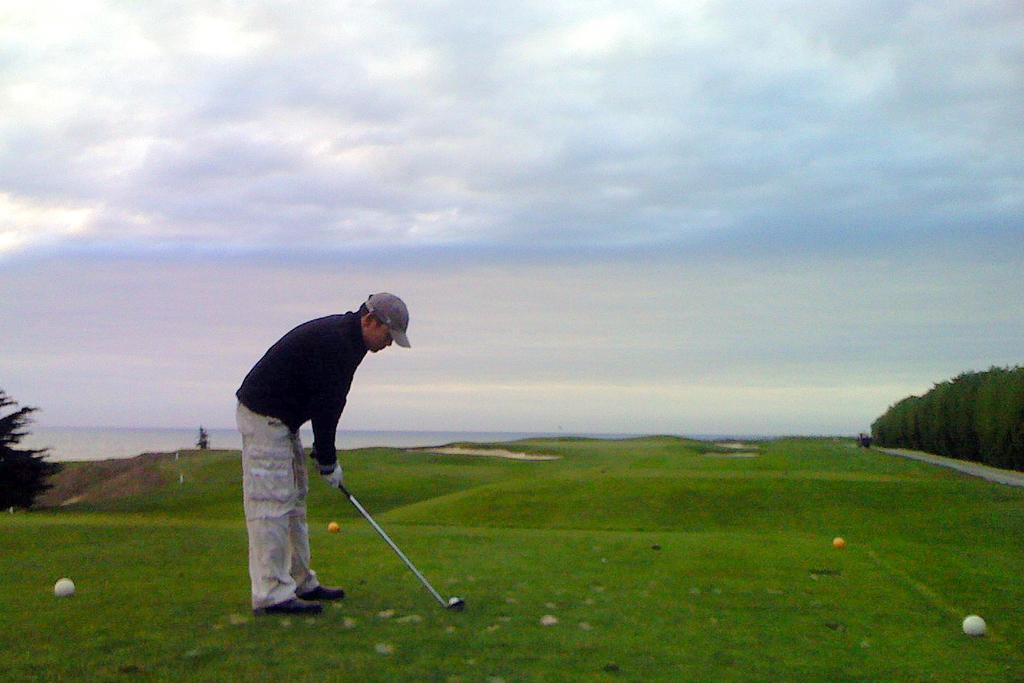Can you describe this image briefly? The man in black T-shirt is holding hockey stick in his hand and he is playing hockey. At the bottom of the picture, we see grass and balls. On either side of the picture, there are trees. At the top of the picture, we see the sky. 